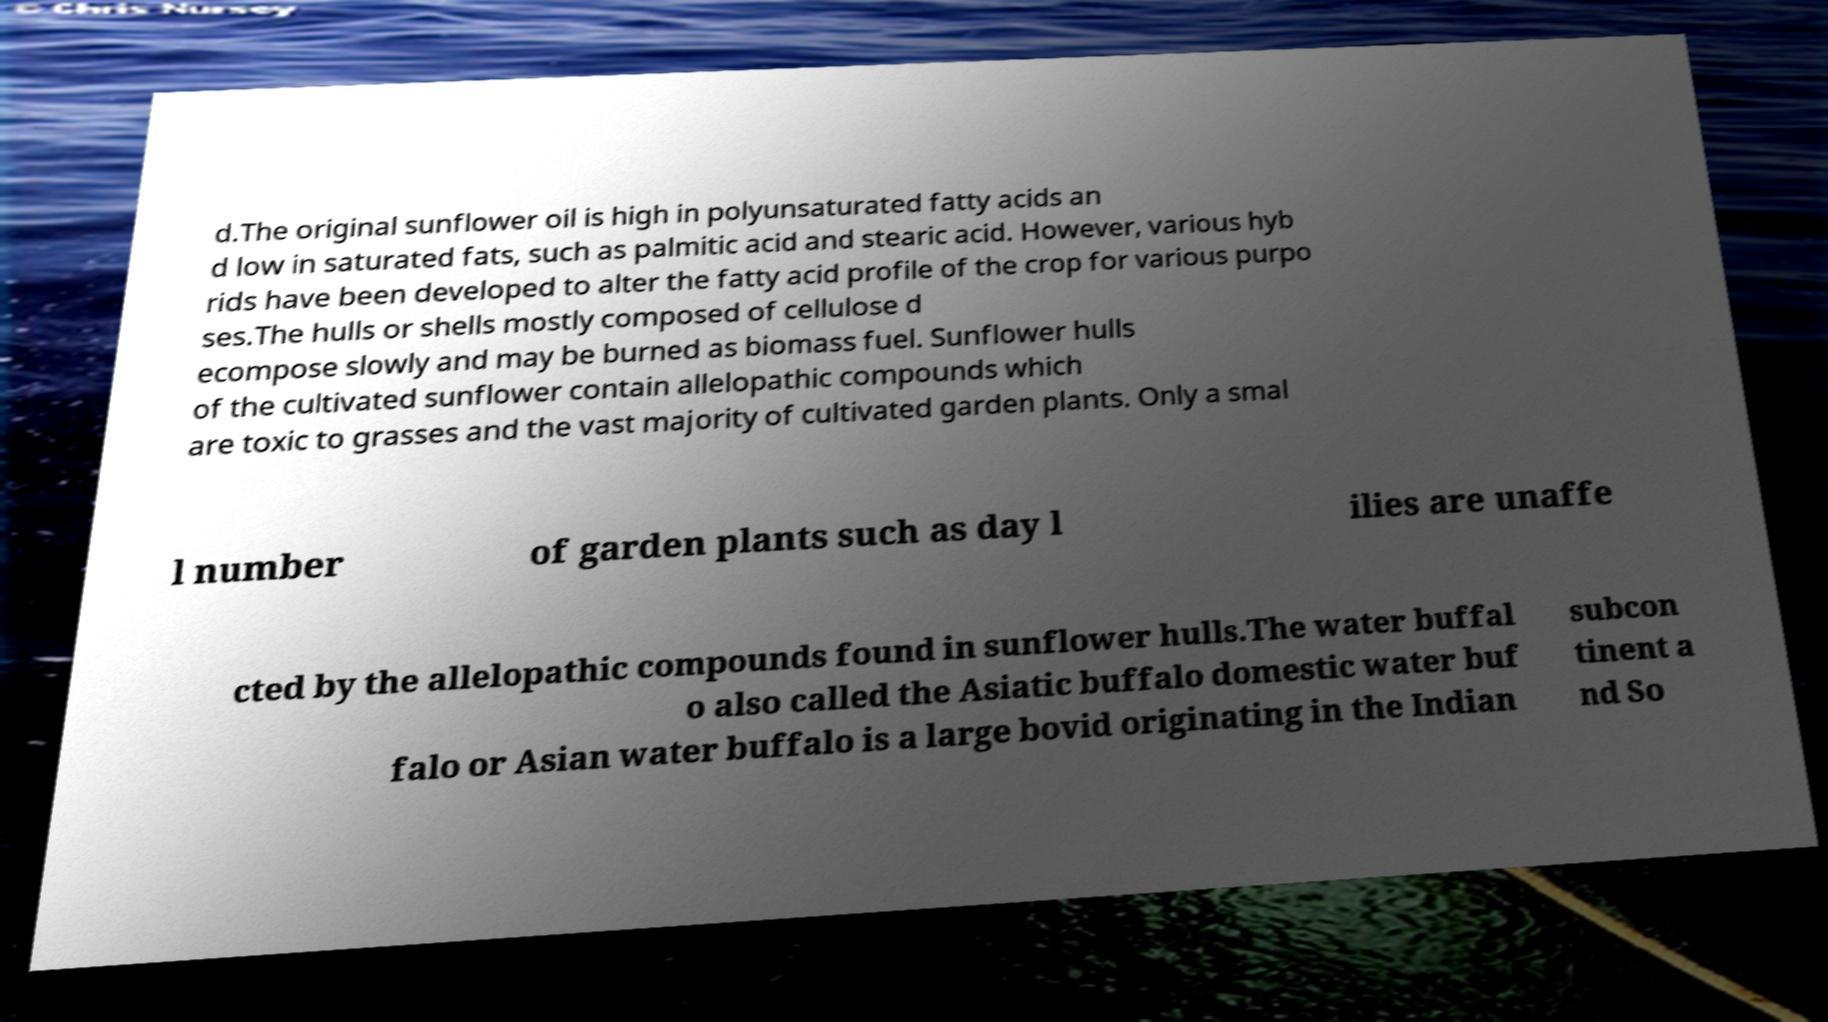Could you assist in decoding the text presented in this image and type it out clearly? d.The original sunflower oil is high in polyunsaturated fatty acids an d low in saturated fats, such as palmitic acid and stearic acid. However, various hyb rids have been developed to alter the fatty acid profile of the crop for various purpo ses.The hulls or shells mostly composed of cellulose d ecompose slowly and may be burned as biomass fuel. Sunflower hulls of the cultivated sunflower contain allelopathic compounds which are toxic to grasses and the vast majority of cultivated garden plants. Only a smal l number of garden plants such as day l ilies are unaffe cted by the allelopathic compounds found in sunflower hulls.The water buffal o also called the Asiatic buffalo domestic water buf falo or Asian water buffalo is a large bovid originating in the Indian subcon tinent a nd So 